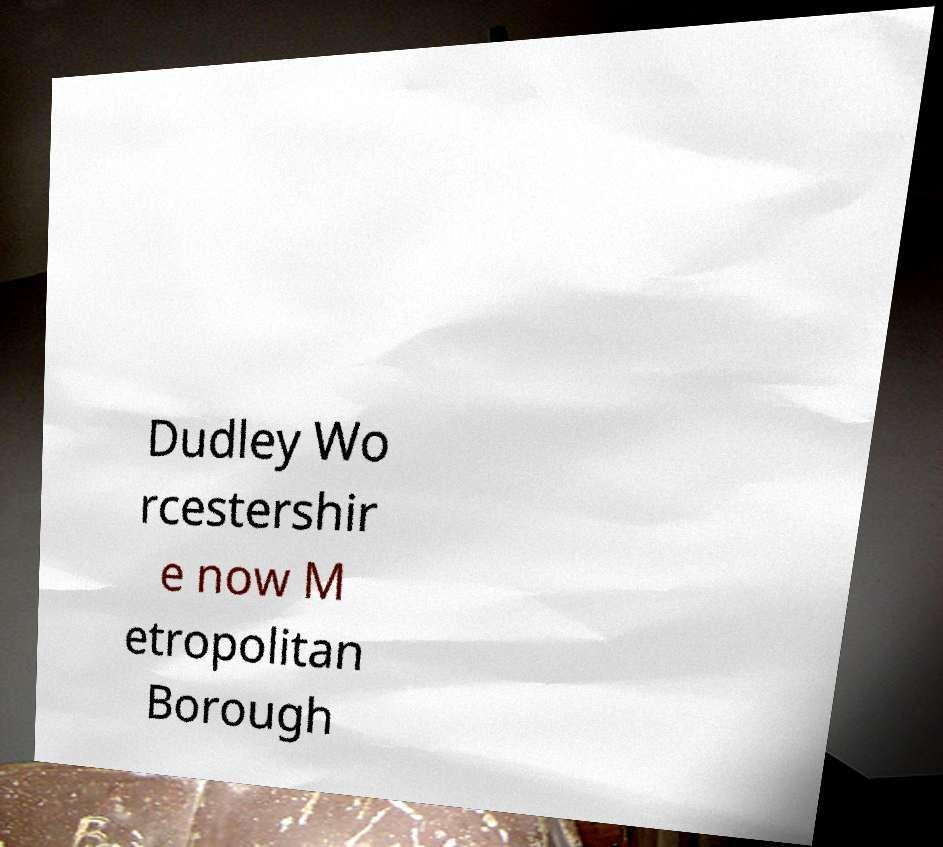I need the written content from this picture converted into text. Can you do that? Dudley Wo rcestershir e now M etropolitan Borough 